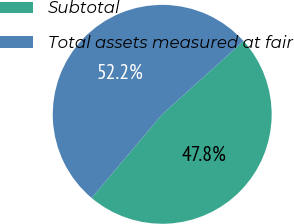Convert chart to OTSL. <chart><loc_0><loc_0><loc_500><loc_500><pie_chart><fcel>Subtotal<fcel>Total assets measured at fair<nl><fcel>47.83%<fcel>52.17%<nl></chart> 